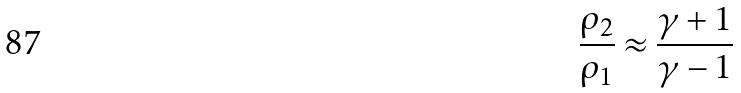Convert formula to latex. <formula><loc_0><loc_0><loc_500><loc_500>\frac { \rho _ { 2 } } { \rho _ { 1 } } \approx \frac { \gamma + 1 } { \gamma - 1 }</formula> 